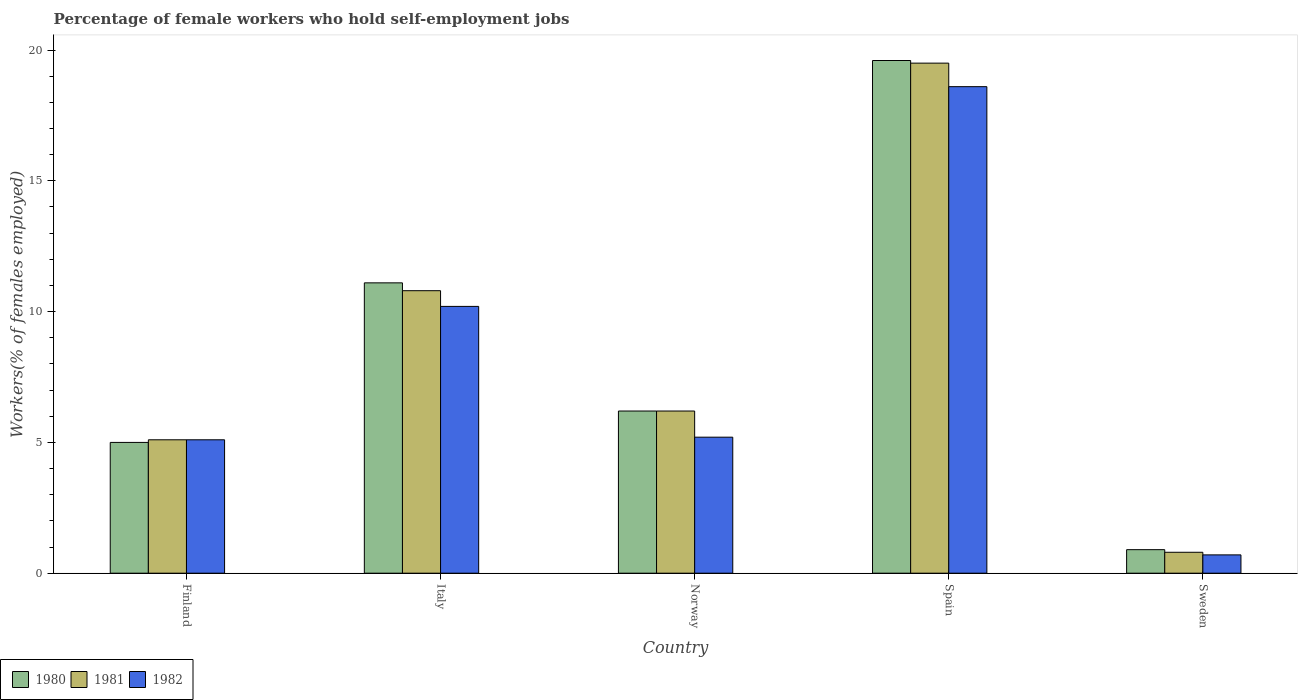How many different coloured bars are there?
Ensure brevity in your answer.  3. How many groups of bars are there?
Ensure brevity in your answer.  5. Are the number of bars per tick equal to the number of legend labels?
Your answer should be very brief. Yes. How many bars are there on the 1st tick from the left?
Your response must be concise. 3. How many bars are there on the 5th tick from the right?
Offer a very short reply. 3. What is the label of the 3rd group of bars from the left?
Your response must be concise. Norway. In how many cases, is the number of bars for a given country not equal to the number of legend labels?
Offer a terse response. 0. What is the percentage of self-employed female workers in 1981 in Finland?
Provide a short and direct response. 5.1. Across all countries, what is the minimum percentage of self-employed female workers in 1981?
Offer a very short reply. 0.8. In which country was the percentage of self-employed female workers in 1980 maximum?
Offer a terse response. Spain. What is the total percentage of self-employed female workers in 1982 in the graph?
Keep it short and to the point. 39.8. What is the difference between the percentage of self-employed female workers in 1980 in Italy and that in Sweden?
Offer a very short reply. 10.2. What is the difference between the percentage of self-employed female workers in 1982 in Italy and the percentage of self-employed female workers in 1980 in Norway?
Keep it short and to the point. 4. What is the average percentage of self-employed female workers in 1981 per country?
Keep it short and to the point. 8.48. What is the difference between the percentage of self-employed female workers of/in 1982 and percentage of self-employed female workers of/in 1980 in Finland?
Your answer should be compact. 0.1. In how many countries, is the percentage of self-employed female workers in 1980 greater than 18 %?
Your answer should be compact. 1. What is the ratio of the percentage of self-employed female workers in 1981 in Italy to that in Norway?
Offer a very short reply. 1.74. Is the percentage of self-employed female workers in 1982 in Norway less than that in Sweden?
Keep it short and to the point. No. What is the difference between the highest and the second highest percentage of self-employed female workers in 1981?
Ensure brevity in your answer.  -8.7. What is the difference between the highest and the lowest percentage of self-employed female workers in 1981?
Offer a very short reply. 18.7. Is the sum of the percentage of self-employed female workers in 1980 in Finland and Sweden greater than the maximum percentage of self-employed female workers in 1982 across all countries?
Keep it short and to the point. No. What does the 2nd bar from the right in Norway represents?
Your answer should be very brief. 1981. Is it the case that in every country, the sum of the percentage of self-employed female workers in 1981 and percentage of self-employed female workers in 1980 is greater than the percentage of self-employed female workers in 1982?
Your answer should be compact. Yes. Are all the bars in the graph horizontal?
Ensure brevity in your answer.  No. How many countries are there in the graph?
Your answer should be very brief. 5. What is the difference between two consecutive major ticks on the Y-axis?
Your answer should be compact. 5. Are the values on the major ticks of Y-axis written in scientific E-notation?
Provide a short and direct response. No. How many legend labels are there?
Your answer should be compact. 3. What is the title of the graph?
Your answer should be very brief. Percentage of female workers who hold self-employment jobs. What is the label or title of the X-axis?
Keep it short and to the point. Country. What is the label or title of the Y-axis?
Ensure brevity in your answer.  Workers(% of females employed). What is the Workers(% of females employed) in 1980 in Finland?
Keep it short and to the point. 5. What is the Workers(% of females employed) of 1981 in Finland?
Your response must be concise. 5.1. What is the Workers(% of females employed) in 1982 in Finland?
Provide a short and direct response. 5.1. What is the Workers(% of females employed) in 1980 in Italy?
Give a very brief answer. 11.1. What is the Workers(% of females employed) of 1981 in Italy?
Offer a terse response. 10.8. What is the Workers(% of females employed) in 1982 in Italy?
Keep it short and to the point. 10.2. What is the Workers(% of females employed) of 1980 in Norway?
Offer a very short reply. 6.2. What is the Workers(% of females employed) in 1981 in Norway?
Offer a very short reply. 6.2. What is the Workers(% of females employed) in 1982 in Norway?
Give a very brief answer. 5.2. What is the Workers(% of females employed) of 1980 in Spain?
Keep it short and to the point. 19.6. What is the Workers(% of females employed) in 1982 in Spain?
Provide a succinct answer. 18.6. What is the Workers(% of females employed) in 1980 in Sweden?
Provide a succinct answer. 0.9. What is the Workers(% of females employed) in 1981 in Sweden?
Offer a very short reply. 0.8. What is the Workers(% of females employed) in 1982 in Sweden?
Offer a terse response. 0.7. Across all countries, what is the maximum Workers(% of females employed) in 1980?
Your answer should be compact. 19.6. Across all countries, what is the maximum Workers(% of females employed) in 1981?
Offer a terse response. 19.5. Across all countries, what is the maximum Workers(% of females employed) of 1982?
Offer a terse response. 18.6. Across all countries, what is the minimum Workers(% of females employed) of 1980?
Make the answer very short. 0.9. Across all countries, what is the minimum Workers(% of females employed) of 1981?
Keep it short and to the point. 0.8. Across all countries, what is the minimum Workers(% of females employed) of 1982?
Keep it short and to the point. 0.7. What is the total Workers(% of females employed) in 1980 in the graph?
Keep it short and to the point. 42.8. What is the total Workers(% of females employed) of 1981 in the graph?
Offer a terse response. 42.4. What is the total Workers(% of females employed) of 1982 in the graph?
Your answer should be compact. 39.8. What is the difference between the Workers(% of females employed) in 1980 in Finland and that in Italy?
Ensure brevity in your answer.  -6.1. What is the difference between the Workers(% of females employed) of 1982 in Finland and that in Italy?
Ensure brevity in your answer.  -5.1. What is the difference between the Workers(% of females employed) in 1980 in Finland and that in Spain?
Keep it short and to the point. -14.6. What is the difference between the Workers(% of females employed) in 1981 in Finland and that in Spain?
Your response must be concise. -14.4. What is the difference between the Workers(% of females employed) of 1980 in Finland and that in Sweden?
Provide a succinct answer. 4.1. What is the difference between the Workers(% of females employed) of 1981 in Finland and that in Sweden?
Make the answer very short. 4.3. What is the difference between the Workers(% of females employed) in 1980 in Italy and that in Norway?
Provide a short and direct response. 4.9. What is the difference between the Workers(% of females employed) of 1980 in Italy and that in Spain?
Provide a short and direct response. -8.5. What is the difference between the Workers(% of females employed) of 1982 in Italy and that in Spain?
Your answer should be very brief. -8.4. What is the difference between the Workers(% of females employed) in 1982 in Italy and that in Sweden?
Offer a very short reply. 9.5. What is the difference between the Workers(% of females employed) in 1980 in Norway and that in Spain?
Your answer should be compact. -13.4. What is the difference between the Workers(% of females employed) in 1981 in Norway and that in Spain?
Your response must be concise. -13.3. What is the difference between the Workers(% of females employed) in 1982 in Norway and that in Spain?
Your answer should be compact. -13.4. What is the difference between the Workers(% of females employed) in 1981 in Norway and that in Sweden?
Provide a short and direct response. 5.4. What is the difference between the Workers(% of females employed) in 1982 in Norway and that in Sweden?
Make the answer very short. 4.5. What is the difference between the Workers(% of females employed) of 1981 in Spain and that in Sweden?
Give a very brief answer. 18.7. What is the difference between the Workers(% of females employed) in 1982 in Spain and that in Sweden?
Your answer should be compact. 17.9. What is the difference between the Workers(% of females employed) in 1980 in Finland and the Workers(% of females employed) in 1981 in Italy?
Your answer should be compact. -5.8. What is the difference between the Workers(% of females employed) in 1981 in Finland and the Workers(% of females employed) in 1982 in Italy?
Provide a short and direct response. -5.1. What is the difference between the Workers(% of females employed) in 1980 in Italy and the Workers(% of females employed) in 1981 in Spain?
Make the answer very short. -8.4. What is the difference between the Workers(% of females employed) of 1981 in Italy and the Workers(% of females employed) of 1982 in Spain?
Make the answer very short. -7.8. What is the difference between the Workers(% of females employed) in 1980 in Italy and the Workers(% of females employed) in 1982 in Sweden?
Make the answer very short. 10.4. What is the difference between the Workers(% of females employed) in 1981 in Italy and the Workers(% of females employed) in 1982 in Sweden?
Ensure brevity in your answer.  10.1. What is the average Workers(% of females employed) in 1980 per country?
Provide a succinct answer. 8.56. What is the average Workers(% of females employed) in 1981 per country?
Your answer should be very brief. 8.48. What is the average Workers(% of females employed) in 1982 per country?
Your answer should be compact. 7.96. What is the difference between the Workers(% of females employed) of 1980 and Workers(% of females employed) of 1981 in Finland?
Your answer should be very brief. -0.1. What is the difference between the Workers(% of females employed) in 1980 and Workers(% of females employed) in 1982 in Italy?
Ensure brevity in your answer.  0.9. What is the difference between the Workers(% of females employed) in 1981 and Workers(% of females employed) in 1982 in Italy?
Your answer should be very brief. 0.6. What is the difference between the Workers(% of females employed) of 1980 and Workers(% of females employed) of 1982 in Norway?
Ensure brevity in your answer.  1. What is the difference between the Workers(% of females employed) of 1980 and Workers(% of females employed) of 1981 in Spain?
Provide a succinct answer. 0.1. What is the difference between the Workers(% of females employed) of 1980 and Workers(% of females employed) of 1982 in Spain?
Keep it short and to the point. 1. What is the difference between the Workers(% of females employed) in 1980 and Workers(% of females employed) in 1981 in Sweden?
Offer a very short reply. 0.1. What is the ratio of the Workers(% of females employed) of 1980 in Finland to that in Italy?
Give a very brief answer. 0.45. What is the ratio of the Workers(% of females employed) of 1981 in Finland to that in Italy?
Offer a terse response. 0.47. What is the ratio of the Workers(% of females employed) of 1980 in Finland to that in Norway?
Provide a succinct answer. 0.81. What is the ratio of the Workers(% of females employed) in 1981 in Finland to that in Norway?
Offer a terse response. 0.82. What is the ratio of the Workers(% of females employed) in 1982 in Finland to that in Norway?
Provide a succinct answer. 0.98. What is the ratio of the Workers(% of females employed) of 1980 in Finland to that in Spain?
Your answer should be compact. 0.26. What is the ratio of the Workers(% of females employed) of 1981 in Finland to that in Spain?
Give a very brief answer. 0.26. What is the ratio of the Workers(% of females employed) in 1982 in Finland to that in Spain?
Provide a succinct answer. 0.27. What is the ratio of the Workers(% of females employed) of 1980 in Finland to that in Sweden?
Give a very brief answer. 5.56. What is the ratio of the Workers(% of females employed) of 1981 in Finland to that in Sweden?
Your response must be concise. 6.38. What is the ratio of the Workers(% of females employed) in 1982 in Finland to that in Sweden?
Your response must be concise. 7.29. What is the ratio of the Workers(% of females employed) in 1980 in Italy to that in Norway?
Offer a very short reply. 1.79. What is the ratio of the Workers(% of females employed) of 1981 in Italy to that in Norway?
Offer a very short reply. 1.74. What is the ratio of the Workers(% of females employed) of 1982 in Italy to that in Norway?
Your answer should be very brief. 1.96. What is the ratio of the Workers(% of females employed) in 1980 in Italy to that in Spain?
Provide a succinct answer. 0.57. What is the ratio of the Workers(% of females employed) in 1981 in Italy to that in Spain?
Offer a terse response. 0.55. What is the ratio of the Workers(% of females employed) in 1982 in Italy to that in Spain?
Offer a very short reply. 0.55. What is the ratio of the Workers(% of females employed) in 1980 in Italy to that in Sweden?
Provide a short and direct response. 12.33. What is the ratio of the Workers(% of females employed) of 1981 in Italy to that in Sweden?
Ensure brevity in your answer.  13.5. What is the ratio of the Workers(% of females employed) of 1982 in Italy to that in Sweden?
Keep it short and to the point. 14.57. What is the ratio of the Workers(% of females employed) of 1980 in Norway to that in Spain?
Offer a terse response. 0.32. What is the ratio of the Workers(% of females employed) of 1981 in Norway to that in Spain?
Your answer should be compact. 0.32. What is the ratio of the Workers(% of females employed) of 1982 in Norway to that in Spain?
Ensure brevity in your answer.  0.28. What is the ratio of the Workers(% of females employed) of 1980 in Norway to that in Sweden?
Your response must be concise. 6.89. What is the ratio of the Workers(% of females employed) in 1981 in Norway to that in Sweden?
Give a very brief answer. 7.75. What is the ratio of the Workers(% of females employed) in 1982 in Norway to that in Sweden?
Offer a very short reply. 7.43. What is the ratio of the Workers(% of females employed) in 1980 in Spain to that in Sweden?
Ensure brevity in your answer.  21.78. What is the ratio of the Workers(% of females employed) of 1981 in Spain to that in Sweden?
Your answer should be compact. 24.38. What is the ratio of the Workers(% of females employed) in 1982 in Spain to that in Sweden?
Your answer should be very brief. 26.57. What is the difference between the highest and the second highest Workers(% of females employed) of 1981?
Offer a terse response. 8.7. 